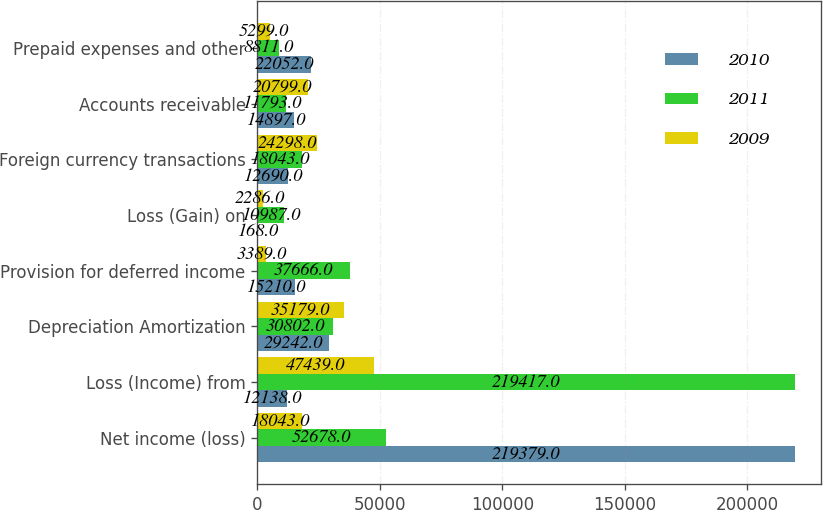<chart> <loc_0><loc_0><loc_500><loc_500><stacked_bar_chart><ecel><fcel>Net income (loss)<fcel>Loss (Income) from<fcel>Depreciation Amortization<fcel>Provision for deferred income<fcel>Loss (Gain) on<fcel>Foreign currency transactions<fcel>Accounts receivable<fcel>Prepaid expenses and other<nl><fcel>2010<fcel>219379<fcel>12138<fcel>29242<fcel>15210<fcel>168<fcel>12690<fcel>14897<fcel>22052<nl><fcel>2011<fcel>52678<fcel>219417<fcel>30802<fcel>37666<fcel>10987<fcel>18043<fcel>11793<fcel>8811<nl><fcel>2009<fcel>18043<fcel>47439<fcel>35179<fcel>3389<fcel>2286<fcel>24298<fcel>20799<fcel>5299<nl></chart> 